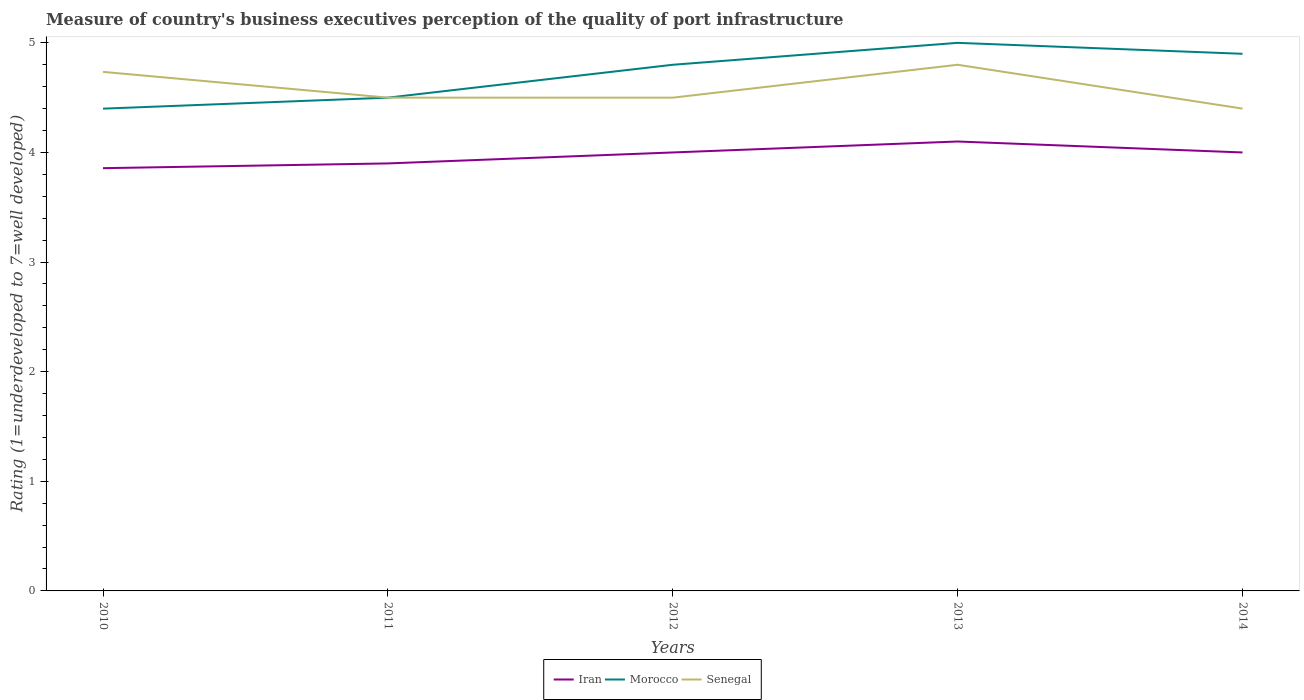How many different coloured lines are there?
Offer a terse response. 3. Does the line corresponding to Senegal intersect with the line corresponding to Iran?
Give a very brief answer. No. Across all years, what is the maximum ratings of the quality of port infrastructure in Iran?
Make the answer very short. 3.86. What is the total ratings of the quality of port infrastructure in Morocco in the graph?
Offer a terse response. -0.1. What is the difference between the highest and the second highest ratings of the quality of port infrastructure in Senegal?
Provide a succinct answer. 0.4. What is the difference between the highest and the lowest ratings of the quality of port infrastructure in Iran?
Make the answer very short. 3. How many lines are there?
Make the answer very short. 3. How many years are there in the graph?
Provide a short and direct response. 5. Does the graph contain any zero values?
Give a very brief answer. No. Does the graph contain grids?
Provide a short and direct response. No. Where does the legend appear in the graph?
Offer a very short reply. Bottom center. What is the title of the graph?
Your answer should be very brief. Measure of country's business executives perception of the quality of port infrastructure. What is the label or title of the Y-axis?
Your response must be concise. Rating (1=underdeveloped to 7=well developed). What is the Rating (1=underdeveloped to 7=well developed) of Iran in 2010?
Give a very brief answer. 3.86. What is the Rating (1=underdeveloped to 7=well developed) in Morocco in 2010?
Offer a terse response. 4.4. What is the Rating (1=underdeveloped to 7=well developed) of Senegal in 2010?
Your answer should be very brief. 4.74. What is the Rating (1=underdeveloped to 7=well developed) of Iran in 2012?
Offer a terse response. 4. What is the Rating (1=underdeveloped to 7=well developed) of Senegal in 2012?
Your answer should be very brief. 4.5. What is the Rating (1=underdeveloped to 7=well developed) in Iran in 2013?
Offer a terse response. 4.1. What is the Rating (1=underdeveloped to 7=well developed) in Morocco in 2013?
Offer a terse response. 5. What is the Rating (1=underdeveloped to 7=well developed) of Senegal in 2013?
Your response must be concise. 4.8. What is the Rating (1=underdeveloped to 7=well developed) in Morocco in 2014?
Provide a succinct answer. 4.9. Across all years, what is the maximum Rating (1=underdeveloped to 7=well developed) of Iran?
Your response must be concise. 4.1. Across all years, what is the minimum Rating (1=underdeveloped to 7=well developed) of Iran?
Ensure brevity in your answer.  3.86. Across all years, what is the minimum Rating (1=underdeveloped to 7=well developed) in Morocco?
Make the answer very short. 4.4. Across all years, what is the minimum Rating (1=underdeveloped to 7=well developed) of Senegal?
Offer a terse response. 4.4. What is the total Rating (1=underdeveloped to 7=well developed) in Iran in the graph?
Offer a very short reply. 19.86. What is the total Rating (1=underdeveloped to 7=well developed) in Morocco in the graph?
Provide a succinct answer. 23.6. What is the total Rating (1=underdeveloped to 7=well developed) of Senegal in the graph?
Offer a terse response. 22.94. What is the difference between the Rating (1=underdeveloped to 7=well developed) of Iran in 2010 and that in 2011?
Provide a succinct answer. -0.04. What is the difference between the Rating (1=underdeveloped to 7=well developed) of Morocco in 2010 and that in 2011?
Make the answer very short. -0.1. What is the difference between the Rating (1=underdeveloped to 7=well developed) of Senegal in 2010 and that in 2011?
Your answer should be compact. 0.24. What is the difference between the Rating (1=underdeveloped to 7=well developed) in Iran in 2010 and that in 2012?
Give a very brief answer. -0.14. What is the difference between the Rating (1=underdeveloped to 7=well developed) in Morocco in 2010 and that in 2012?
Provide a succinct answer. -0.4. What is the difference between the Rating (1=underdeveloped to 7=well developed) in Senegal in 2010 and that in 2012?
Give a very brief answer. 0.24. What is the difference between the Rating (1=underdeveloped to 7=well developed) in Iran in 2010 and that in 2013?
Your answer should be compact. -0.24. What is the difference between the Rating (1=underdeveloped to 7=well developed) in Morocco in 2010 and that in 2013?
Provide a short and direct response. -0.6. What is the difference between the Rating (1=underdeveloped to 7=well developed) of Senegal in 2010 and that in 2013?
Your response must be concise. -0.06. What is the difference between the Rating (1=underdeveloped to 7=well developed) of Iran in 2010 and that in 2014?
Your answer should be compact. -0.14. What is the difference between the Rating (1=underdeveloped to 7=well developed) of Morocco in 2010 and that in 2014?
Keep it short and to the point. -0.5. What is the difference between the Rating (1=underdeveloped to 7=well developed) in Senegal in 2010 and that in 2014?
Your answer should be very brief. 0.34. What is the difference between the Rating (1=underdeveloped to 7=well developed) of Senegal in 2011 and that in 2012?
Provide a succinct answer. 0. What is the difference between the Rating (1=underdeveloped to 7=well developed) in Morocco in 2011 and that in 2013?
Your answer should be compact. -0.5. What is the difference between the Rating (1=underdeveloped to 7=well developed) in Morocco in 2012 and that in 2013?
Provide a succinct answer. -0.2. What is the difference between the Rating (1=underdeveloped to 7=well developed) in Senegal in 2012 and that in 2013?
Provide a succinct answer. -0.3. What is the difference between the Rating (1=underdeveloped to 7=well developed) in Iran in 2012 and that in 2014?
Provide a short and direct response. 0. What is the difference between the Rating (1=underdeveloped to 7=well developed) of Senegal in 2012 and that in 2014?
Make the answer very short. 0.1. What is the difference between the Rating (1=underdeveloped to 7=well developed) of Iran in 2013 and that in 2014?
Offer a terse response. 0.1. What is the difference between the Rating (1=underdeveloped to 7=well developed) in Morocco in 2013 and that in 2014?
Give a very brief answer. 0.1. What is the difference between the Rating (1=underdeveloped to 7=well developed) of Senegal in 2013 and that in 2014?
Provide a succinct answer. 0.4. What is the difference between the Rating (1=underdeveloped to 7=well developed) in Iran in 2010 and the Rating (1=underdeveloped to 7=well developed) in Morocco in 2011?
Offer a terse response. -0.64. What is the difference between the Rating (1=underdeveloped to 7=well developed) of Iran in 2010 and the Rating (1=underdeveloped to 7=well developed) of Senegal in 2011?
Your answer should be very brief. -0.64. What is the difference between the Rating (1=underdeveloped to 7=well developed) in Morocco in 2010 and the Rating (1=underdeveloped to 7=well developed) in Senegal in 2011?
Provide a short and direct response. -0.1. What is the difference between the Rating (1=underdeveloped to 7=well developed) in Iran in 2010 and the Rating (1=underdeveloped to 7=well developed) in Morocco in 2012?
Keep it short and to the point. -0.94. What is the difference between the Rating (1=underdeveloped to 7=well developed) of Iran in 2010 and the Rating (1=underdeveloped to 7=well developed) of Senegal in 2012?
Your answer should be very brief. -0.64. What is the difference between the Rating (1=underdeveloped to 7=well developed) in Morocco in 2010 and the Rating (1=underdeveloped to 7=well developed) in Senegal in 2012?
Your answer should be very brief. -0.1. What is the difference between the Rating (1=underdeveloped to 7=well developed) of Iran in 2010 and the Rating (1=underdeveloped to 7=well developed) of Morocco in 2013?
Provide a short and direct response. -1.14. What is the difference between the Rating (1=underdeveloped to 7=well developed) in Iran in 2010 and the Rating (1=underdeveloped to 7=well developed) in Senegal in 2013?
Provide a succinct answer. -0.94. What is the difference between the Rating (1=underdeveloped to 7=well developed) of Morocco in 2010 and the Rating (1=underdeveloped to 7=well developed) of Senegal in 2013?
Ensure brevity in your answer.  -0.4. What is the difference between the Rating (1=underdeveloped to 7=well developed) in Iran in 2010 and the Rating (1=underdeveloped to 7=well developed) in Morocco in 2014?
Your answer should be compact. -1.04. What is the difference between the Rating (1=underdeveloped to 7=well developed) of Iran in 2010 and the Rating (1=underdeveloped to 7=well developed) of Senegal in 2014?
Keep it short and to the point. -0.54. What is the difference between the Rating (1=underdeveloped to 7=well developed) of Morocco in 2010 and the Rating (1=underdeveloped to 7=well developed) of Senegal in 2014?
Your response must be concise. -0. What is the difference between the Rating (1=underdeveloped to 7=well developed) in Iran in 2011 and the Rating (1=underdeveloped to 7=well developed) in Morocco in 2012?
Offer a very short reply. -0.9. What is the difference between the Rating (1=underdeveloped to 7=well developed) in Iran in 2011 and the Rating (1=underdeveloped to 7=well developed) in Senegal in 2012?
Offer a very short reply. -0.6. What is the difference between the Rating (1=underdeveloped to 7=well developed) of Iran in 2011 and the Rating (1=underdeveloped to 7=well developed) of Senegal in 2013?
Ensure brevity in your answer.  -0.9. What is the difference between the Rating (1=underdeveloped to 7=well developed) in Iran in 2012 and the Rating (1=underdeveloped to 7=well developed) in Senegal in 2013?
Provide a succinct answer. -0.8. What is the difference between the Rating (1=underdeveloped to 7=well developed) in Morocco in 2012 and the Rating (1=underdeveloped to 7=well developed) in Senegal in 2013?
Keep it short and to the point. 0. What is the difference between the Rating (1=underdeveloped to 7=well developed) of Iran in 2012 and the Rating (1=underdeveloped to 7=well developed) of Senegal in 2014?
Provide a short and direct response. -0.4. What is the difference between the Rating (1=underdeveloped to 7=well developed) of Iran in 2013 and the Rating (1=underdeveloped to 7=well developed) of Senegal in 2014?
Provide a short and direct response. -0.3. What is the average Rating (1=underdeveloped to 7=well developed) in Iran per year?
Give a very brief answer. 3.97. What is the average Rating (1=underdeveloped to 7=well developed) of Morocco per year?
Your response must be concise. 4.72. What is the average Rating (1=underdeveloped to 7=well developed) of Senegal per year?
Keep it short and to the point. 4.59. In the year 2010, what is the difference between the Rating (1=underdeveloped to 7=well developed) of Iran and Rating (1=underdeveloped to 7=well developed) of Morocco?
Keep it short and to the point. -0.54. In the year 2010, what is the difference between the Rating (1=underdeveloped to 7=well developed) in Iran and Rating (1=underdeveloped to 7=well developed) in Senegal?
Your answer should be compact. -0.88. In the year 2010, what is the difference between the Rating (1=underdeveloped to 7=well developed) of Morocco and Rating (1=underdeveloped to 7=well developed) of Senegal?
Provide a succinct answer. -0.34. In the year 2011, what is the difference between the Rating (1=underdeveloped to 7=well developed) in Iran and Rating (1=underdeveloped to 7=well developed) in Morocco?
Offer a very short reply. -0.6. In the year 2013, what is the difference between the Rating (1=underdeveloped to 7=well developed) of Morocco and Rating (1=underdeveloped to 7=well developed) of Senegal?
Offer a terse response. 0.2. In the year 2014, what is the difference between the Rating (1=underdeveloped to 7=well developed) in Iran and Rating (1=underdeveloped to 7=well developed) in Morocco?
Offer a very short reply. -0.9. In the year 2014, what is the difference between the Rating (1=underdeveloped to 7=well developed) of Iran and Rating (1=underdeveloped to 7=well developed) of Senegal?
Your response must be concise. -0.4. What is the ratio of the Rating (1=underdeveloped to 7=well developed) of Iran in 2010 to that in 2011?
Offer a terse response. 0.99. What is the ratio of the Rating (1=underdeveloped to 7=well developed) in Morocco in 2010 to that in 2011?
Provide a short and direct response. 0.98. What is the ratio of the Rating (1=underdeveloped to 7=well developed) in Senegal in 2010 to that in 2011?
Offer a terse response. 1.05. What is the ratio of the Rating (1=underdeveloped to 7=well developed) in Iran in 2010 to that in 2012?
Keep it short and to the point. 0.96. What is the ratio of the Rating (1=underdeveloped to 7=well developed) of Morocco in 2010 to that in 2012?
Your answer should be very brief. 0.92. What is the ratio of the Rating (1=underdeveloped to 7=well developed) of Senegal in 2010 to that in 2012?
Offer a terse response. 1.05. What is the ratio of the Rating (1=underdeveloped to 7=well developed) of Iran in 2010 to that in 2013?
Your answer should be very brief. 0.94. What is the ratio of the Rating (1=underdeveloped to 7=well developed) in Morocco in 2010 to that in 2013?
Ensure brevity in your answer.  0.88. What is the ratio of the Rating (1=underdeveloped to 7=well developed) in Senegal in 2010 to that in 2013?
Provide a succinct answer. 0.99. What is the ratio of the Rating (1=underdeveloped to 7=well developed) in Iran in 2010 to that in 2014?
Make the answer very short. 0.96. What is the ratio of the Rating (1=underdeveloped to 7=well developed) in Morocco in 2010 to that in 2014?
Your response must be concise. 0.9. What is the ratio of the Rating (1=underdeveloped to 7=well developed) of Senegal in 2010 to that in 2014?
Your answer should be compact. 1.08. What is the ratio of the Rating (1=underdeveloped to 7=well developed) of Iran in 2011 to that in 2012?
Make the answer very short. 0.97. What is the ratio of the Rating (1=underdeveloped to 7=well developed) in Senegal in 2011 to that in 2012?
Make the answer very short. 1. What is the ratio of the Rating (1=underdeveloped to 7=well developed) in Iran in 2011 to that in 2013?
Provide a short and direct response. 0.95. What is the ratio of the Rating (1=underdeveloped to 7=well developed) in Senegal in 2011 to that in 2013?
Ensure brevity in your answer.  0.94. What is the ratio of the Rating (1=underdeveloped to 7=well developed) in Iran in 2011 to that in 2014?
Provide a succinct answer. 0.97. What is the ratio of the Rating (1=underdeveloped to 7=well developed) of Morocco in 2011 to that in 2014?
Your answer should be very brief. 0.92. What is the ratio of the Rating (1=underdeveloped to 7=well developed) of Senegal in 2011 to that in 2014?
Ensure brevity in your answer.  1.02. What is the ratio of the Rating (1=underdeveloped to 7=well developed) of Iran in 2012 to that in 2013?
Keep it short and to the point. 0.98. What is the ratio of the Rating (1=underdeveloped to 7=well developed) of Morocco in 2012 to that in 2013?
Your response must be concise. 0.96. What is the ratio of the Rating (1=underdeveloped to 7=well developed) of Senegal in 2012 to that in 2013?
Your answer should be very brief. 0.94. What is the ratio of the Rating (1=underdeveloped to 7=well developed) in Iran in 2012 to that in 2014?
Give a very brief answer. 1. What is the ratio of the Rating (1=underdeveloped to 7=well developed) of Morocco in 2012 to that in 2014?
Your response must be concise. 0.98. What is the ratio of the Rating (1=underdeveloped to 7=well developed) of Senegal in 2012 to that in 2014?
Provide a short and direct response. 1.02. What is the ratio of the Rating (1=underdeveloped to 7=well developed) of Morocco in 2013 to that in 2014?
Keep it short and to the point. 1.02. What is the ratio of the Rating (1=underdeveloped to 7=well developed) of Senegal in 2013 to that in 2014?
Your answer should be very brief. 1.09. What is the difference between the highest and the second highest Rating (1=underdeveloped to 7=well developed) of Senegal?
Offer a very short reply. 0.06. What is the difference between the highest and the lowest Rating (1=underdeveloped to 7=well developed) of Iran?
Provide a succinct answer. 0.24. What is the difference between the highest and the lowest Rating (1=underdeveloped to 7=well developed) of Morocco?
Give a very brief answer. 0.6. 